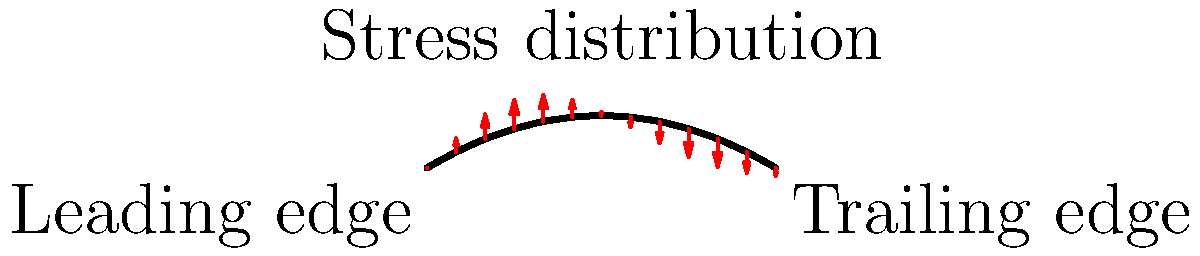In the finite element analysis of a jet engine turbine blade shown above, which region is likely to experience the highest stress concentration, and why? To determine the region of highest stress concentration in the turbine blade, we need to consider several factors:

1. Geometry: The shape of the blade affects stress distribution. Areas with sharp changes in geometry often lead to stress concentrations.

2. Load distribution: The arrows in the diagram represent the stress distribution along the blade.

3. Blade curvature: The curvature of the blade affects how stresses are distributed.

4. Aerodynamic forces: Although not explicitly shown, the blade experiences complex aerodynamic forces during operation.

Analyzing the given diagram:

1. The leading edge (left side) of the blade has a relatively sharp curve, which can lead to stress concentration.

2. The stress arrows are longest near the middle of the blade, indicating higher stress in this region.

3. The trailing edge (right side) is thinner and more susceptible to deformation.

4. The maximum curvature occurs around 1/3 of the blade length from the leading edge.

Considering these factors, the region most likely to experience the highest stress concentration is near the point of maximum curvature, approximately 1/3 of the blade length from the leading edge. This area combines high curvature (geometric stress concentration) with significant aerodynamic loading (indicated by longer stress arrows).

In finite element analysis, this region would require a finer mesh to accurately capture the stress gradients and potential stress concentration effects.
Answer: Approximately 1/3 of the blade length from the leading edge, where curvature is maximum and stress arrows are longest. 